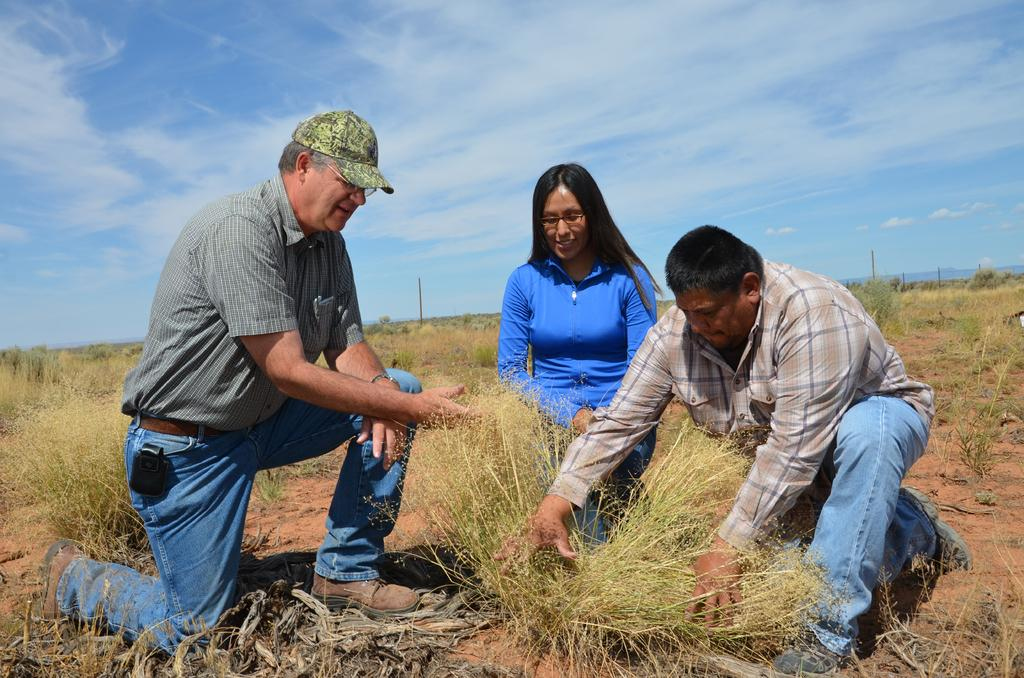How many people are in the image? There are three persons in the image. What is one person wearing that is unique to them? One person is wearing a cap and specs. What type of surface is on the ground in the image? There is grass on the ground in the image. What can be seen in the background of the image? There is sky visible in the background of the image. What is present in the sky? Clouds are present in the sky. What type of copper object can be seen in the image? There is no copper object present in the image. Is there a playground visible in the image? There is no playground visible in the image. 